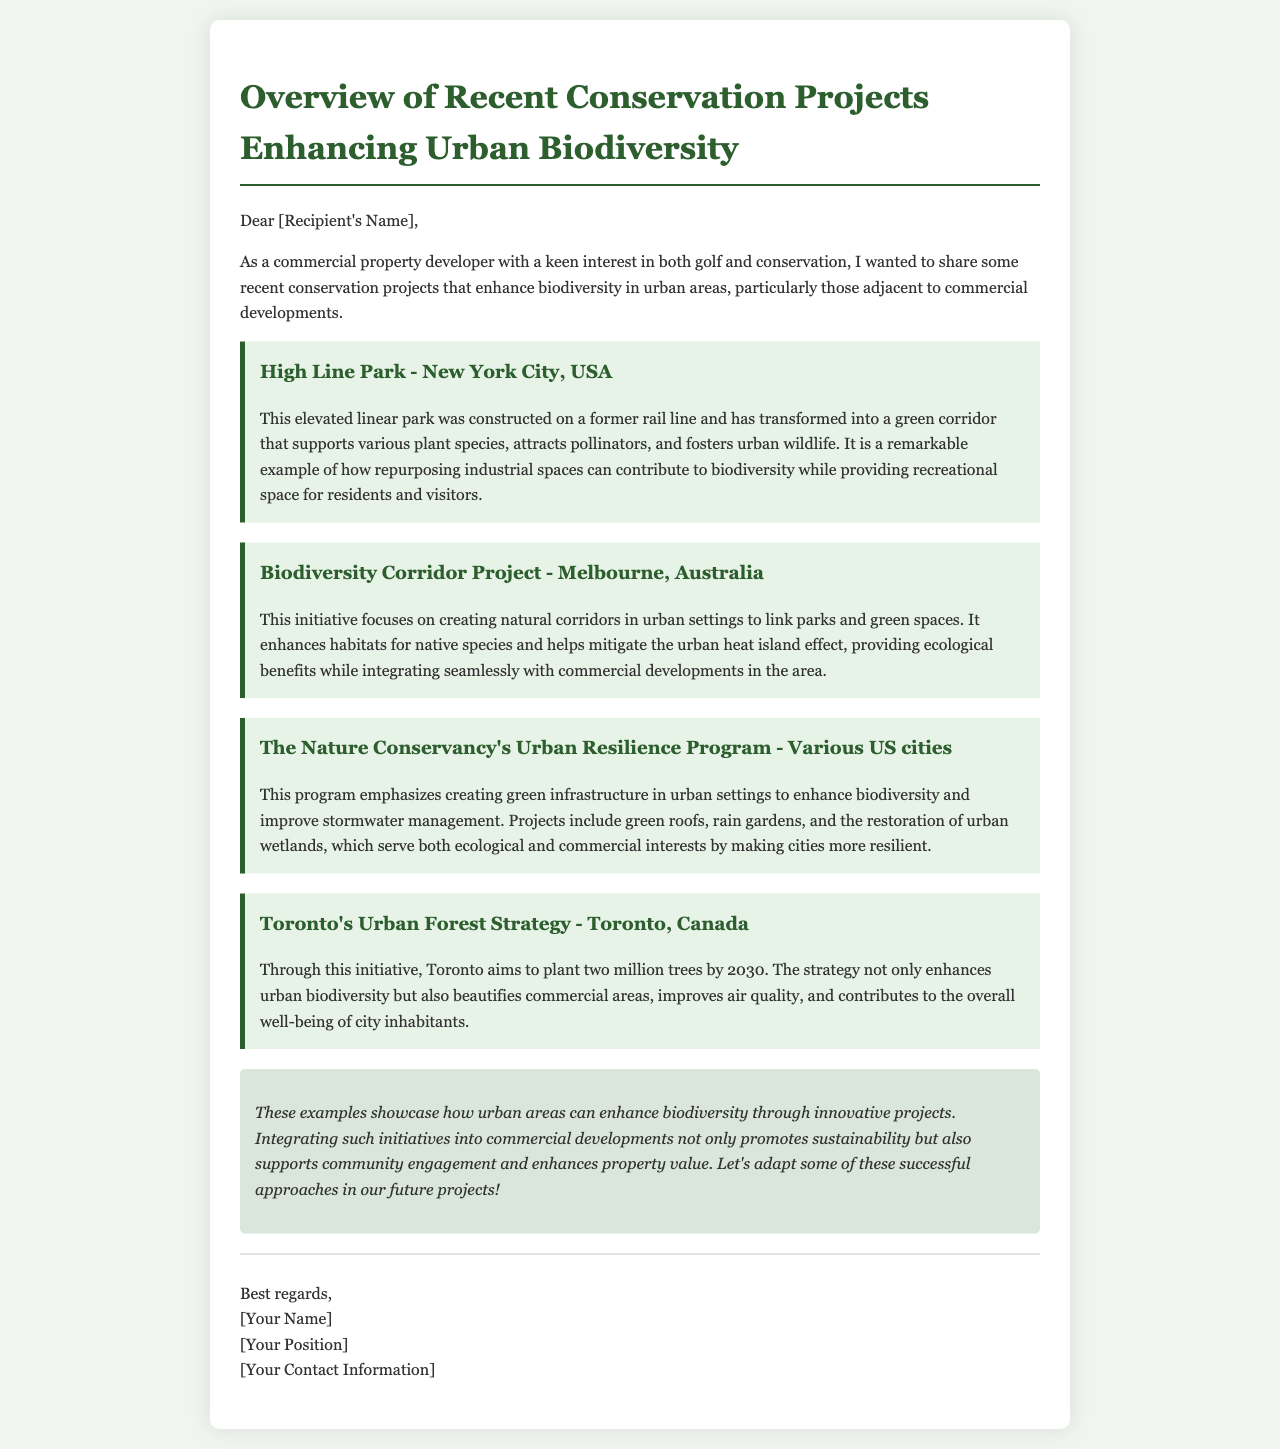What is the main focus of the email? The email focuses on recent conservation projects that enhance biodiversity in urban areas adjacent to commercial developments.
Answer: Conservation projects How many trees does Toronto aim to plant by 2030? The document states that Toronto aims to plant two million trees by 2030 as part of its Urban Forest Strategy.
Answer: Two million What project is an example of repurposing industrial spaces? The High Line Park in New York City is highlighted as an example of repurposing industrial spaces into green corridors.
Answer: High Line Park What initiative links parks and green spaces in Melbourne? The Biodiversity Corridor Project focuses on creating natural corridors in urban settings to link parks and green spaces.
Answer: Biodiversity Corridor Project What type of infrastructure does The Nature Conservancy's Urban Resilience Program emphasize? The program emphasizes creating green infrastructure in urban settings to enhance biodiversity and improve stormwater management.
Answer: Green infrastructure What ecological benefit does the Biodiversity Corridor Project provide? The project helps mitigate the urban heat island effect while enhancing habitats for native species.
Answer: Mitigate urban heat island effect What is the closing remark of the email regarding future projects? The closing remark suggests adapting successful approaches from the mentioned projects in future developments.
Answer: Adapt successful approaches 